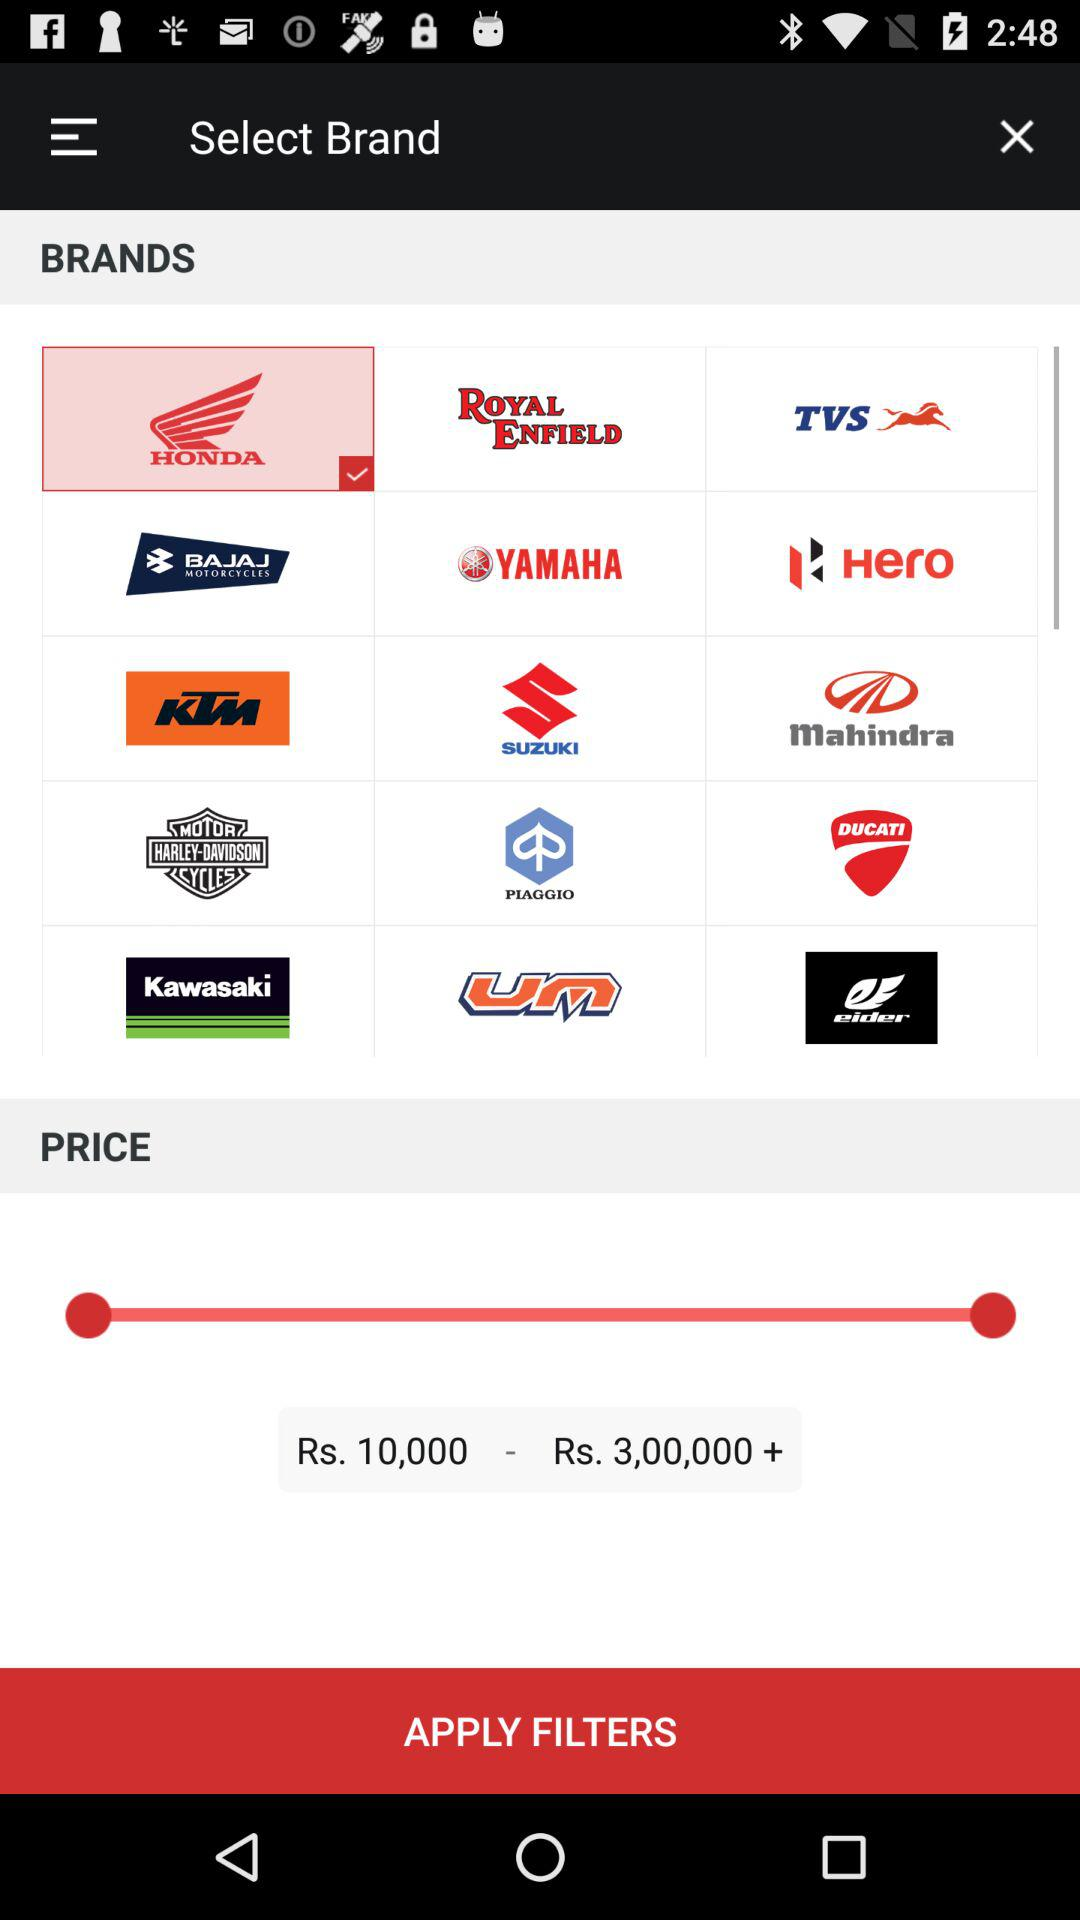What is the price range? The price range is from Rs. 10,000 to more than Rs. 3,00,000. 